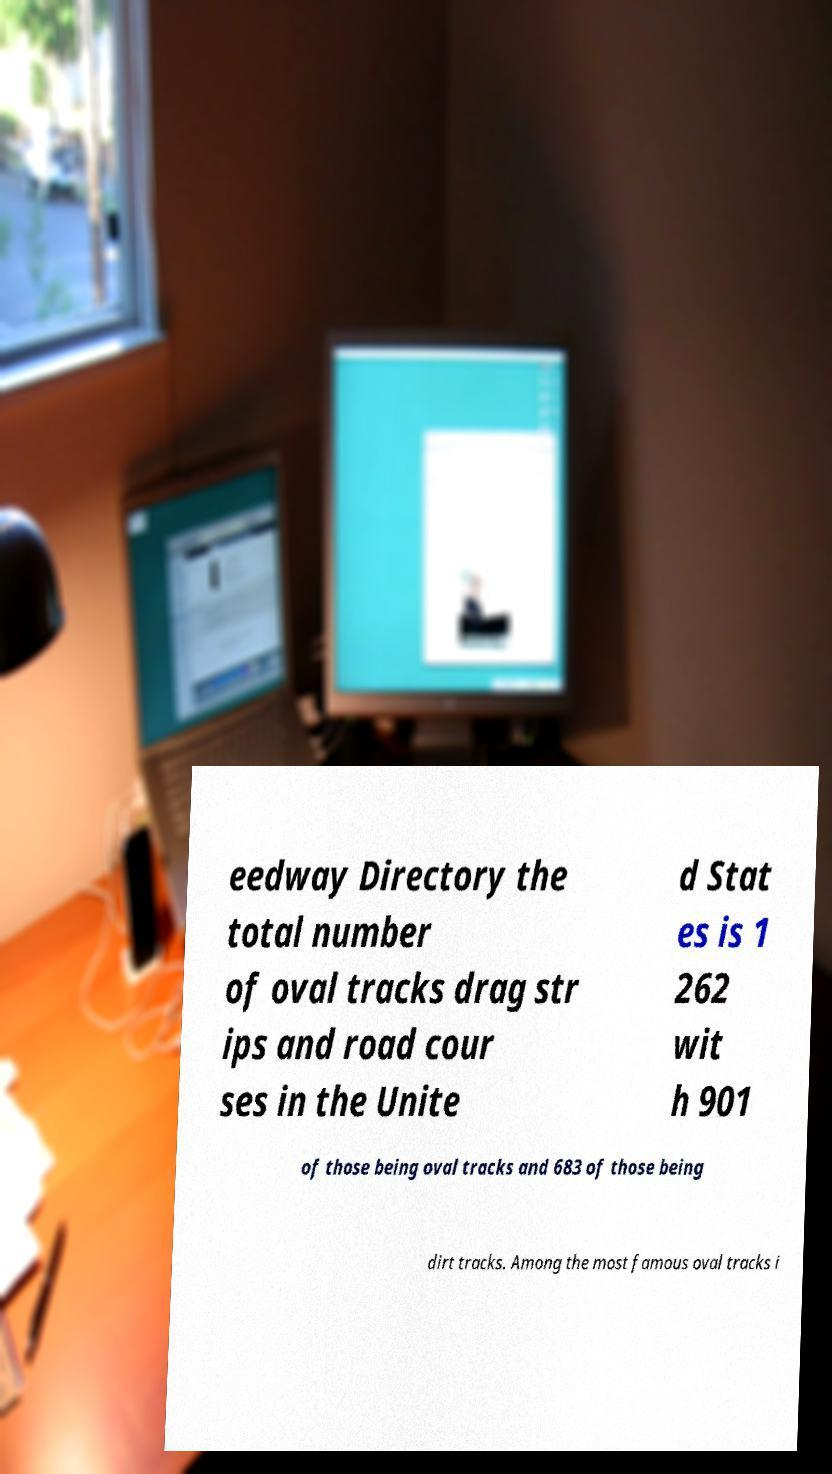Could you extract and type out the text from this image? eedway Directory the total number of oval tracks drag str ips and road cour ses in the Unite d Stat es is 1 262 wit h 901 of those being oval tracks and 683 of those being dirt tracks. Among the most famous oval tracks i 